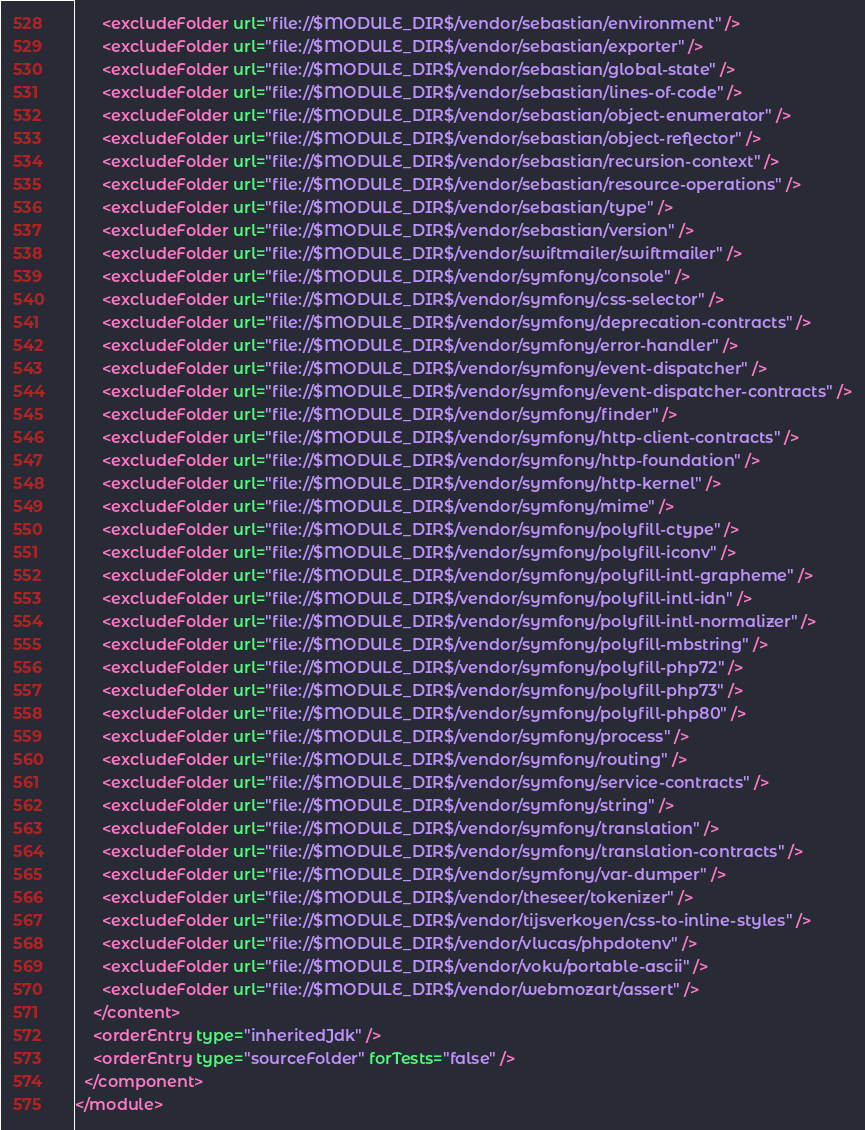Convert code to text. <code><loc_0><loc_0><loc_500><loc_500><_XML_>      <excludeFolder url="file://$MODULE_DIR$/vendor/sebastian/environment" />
      <excludeFolder url="file://$MODULE_DIR$/vendor/sebastian/exporter" />
      <excludeFolder url="file://$MODULE_DIR$/vendor/sebastian/global-state" />
      <excludeFolder url="file://$MODULE_DIR$/vendor/sebastian/lines-of-code" />
      <excludeFolder url="file://$MODULE_DIR$/vendor/sebastian/object-enumerator" />
      <excludeFolder url="file://$MODULE_DIR$/vendor/sebastian/object-reflector" />
      <excludeFolder url="file://$MODULE_DIR$/vendor/sebastian/recursion-context" />
      <excludeFolder url="file://$MODULE_DIR$/vendor/sebastian/resource-operations" />
      <excludeFolder url="file://$MODULE_DIR$/vendor/sebastian/type" />
      <excludeFolder url="file://$MODULE_DIR$/vendor/sebastian/version" />
      <excludeFolder url="file://$MODULE_DIR$/vendor/swiftmailer/swiftmailer" />
      <excludeFolder url="file://$MODULE_DIR$/vendor/symfony/console" />
      <excludeFolder url="file://$MODULE_DIR$/vendor/symfony/css-selector" />
      <excludeFolder url="file://$MODULE_DIR$/vendor/symfony/deprecation-contracts" />
      <excludeFolder url="file://$MODULE_DIR$/vendor/symfony/error-handler" />
      <excludeFolder url="file://$MODULE_DIR$/vendor/symfony/event-dispatcher" />
      <excludeFolder url="file://$MODULE_DIR$/vendor/symfony/event-dispatcher-contracts" />
      <excludeFolder url="file://$MODULE_DIR$/vendor/symfony/finder" />
      <excludeFolder url="file://$MODULE_DIR$/vendor/symfony/http-client-contracts" />
      <excludeFolder url="file://$MODULE_DIR$/vendor/symfony/http-foundation" />
      <excludeFolder url="file://$MODULE_DIR$/vendor/symfony/http-kernel" />
      <excludeFolder url="file://$MODULE_DIR$/vendor/symfony/mime" />
      <excludeFolder url="file://$MODULE_DIR$/vendor/symfony/polyfill-ctype" />
      <excludeFolder url="file://$MODULE_DIR$/vendor/symfony/polyfill-iconv" />
      <excludeFolder url="file://$MODULE_DIR$/vendor/symfony/polyfill-intl-grapheme" />
      <excludeFolder url="file://$MODULE_DIR$/vendor/symfony/polyfill-intl-idn" />
      <excludeFolder url="file://$MODULE_DIR$/vendor/symfony/polyfill-intl-normalizer" />
      <excludeFolder url="file://$MODULE_DIR$/vendor/symfony/polyfill-mbstring" />
      <excludeFolder url="file://$MODULE_DIR$/vendor/symfony/polyfill-php72" />
      <excludeFolder url="file://$MODULE_DIR$/vendor/symfony/polyfill-php73" />
      <excludeFolder url="file://$MODULE_DIR$/vendor/symfony/polyfill-php80" />
      <excludeFolder url="file://$MODULE_DIR$/vendor/symfony/process" />
      <excludeFolder url="file://$MODULE_DIR$/vendor/symfony/routing" />
      <excludeFolder url="file://$MODULE_DIR$/vendor/symfony/service-contracts" />
      <excludeFolder url="file://$MODULE_DIR$/vendor/symfony/string" />
      <excludeFolder url="file://$MODULE_DIR$/vendor/symfony/translation" />
      <excludeFolder url="file://$MODULE_DIR$/vendor/symfony/translation-contracts" />
      <excludeFolder url="file://$MODULE_DIR$/vendor/symfony/var-dumper" />
      <excludeFolder url="file://$MODULE_DIR$/vendor/theseer/tokenizer" />
      <excludeFolder url="file://$MODULE_DIR$/vendor/tijsverkoyen/css-to-inline-styles" />
      <excludeFolder url="file://$MODULE_DIR$/vendor/vlucas/phpdotenv" />
      <excludeFolder url="file://$MODULE_DIR$/vendor/voku/portable-ascii" />
      <excludeFolder url="file://$MODULE_DIR$/vendor/webmozart/assert" />
    </content>
    <orderEntry type="inheritedJdk" />
    <orderEntry type="sourceFolder" forTests="false" />
  </component>
</module></code> 